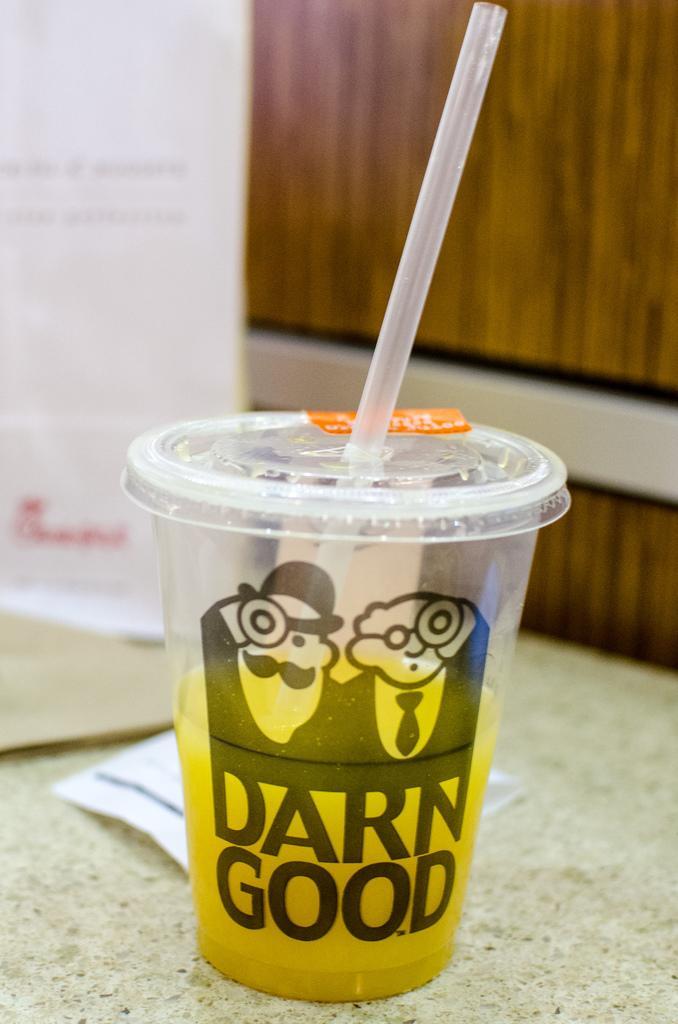Could you give a brief overview of what you see in this image? In the picture we can see a glass with a soft drink and a straw in it and in the background, we can see a wall with a wooden plank. 